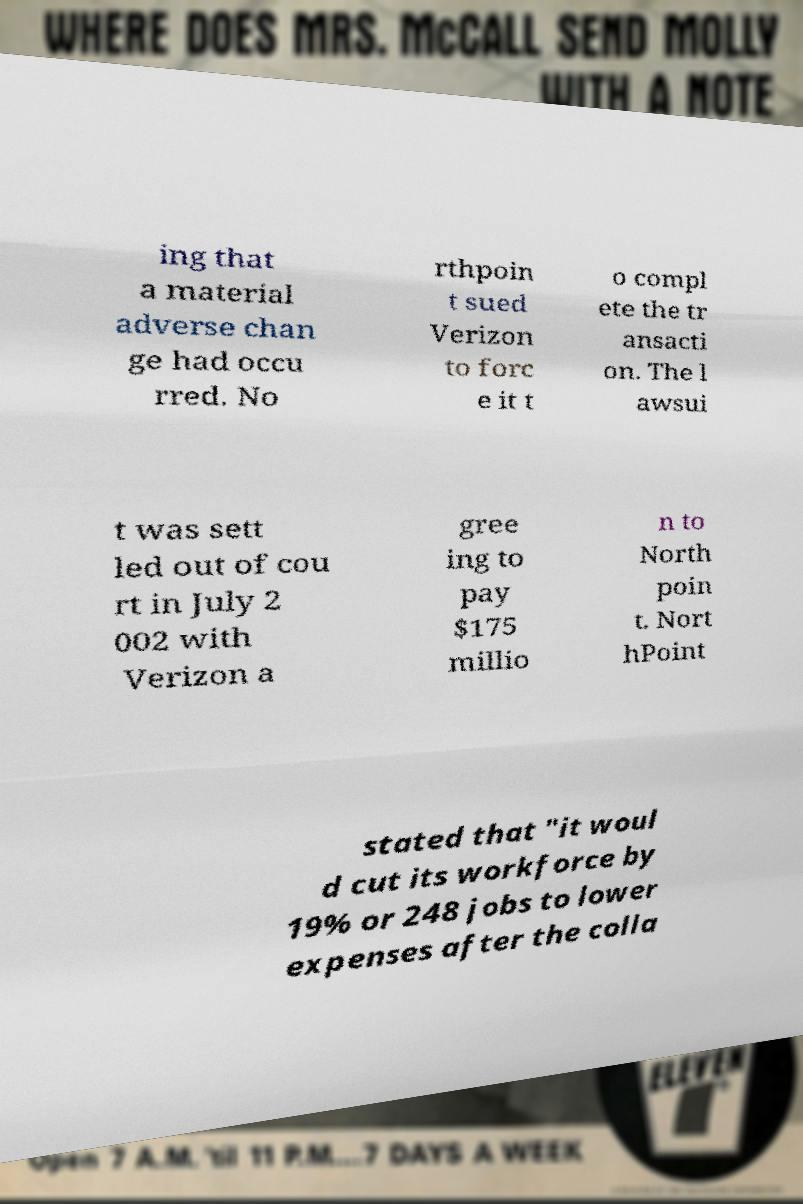I need the written content from this picture converted into text. Can you do that? ing that a material adverse chan ge had occu rred. No rthpoin t sued Verizon to forc e it t o compl ete the tr ansacti on. The l awsui t was sett led out of cou rt in July 2 002 with Verizon a gree ing to pay $175 millio n to North poin t. Nort hPoint stated that "it woul d cut its workforce by 19% or 248 jobs to lower expenses after the colla 